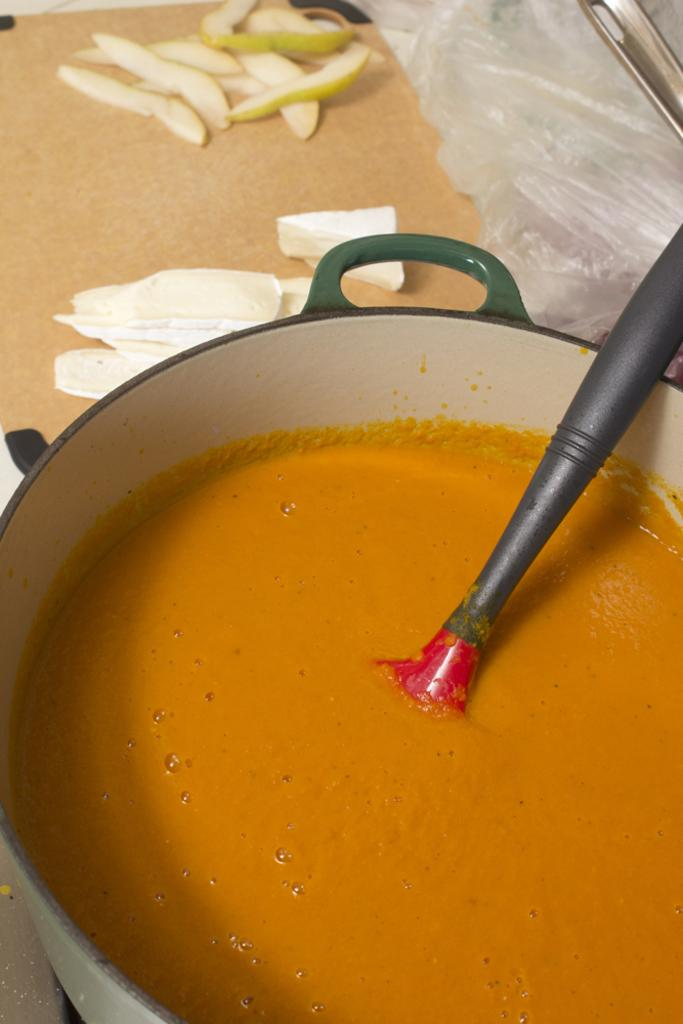What type of food is visible in the image? There are vegetable slices in the image. What is located on the table in the image? There are objects on the table in the image. What can be seen in the foreground of the image? In the foreground, there appears to be a batter in a bowl. What utensil is used with the batter in the image? There is a spoon in the bowl with the batter. How many men are present in the image? There is no information about men in the image; it only shows vegetable slices, objects on a table, and a batter in a bowl. What type of minister is depicted in the image? There is no minister present in the image. 